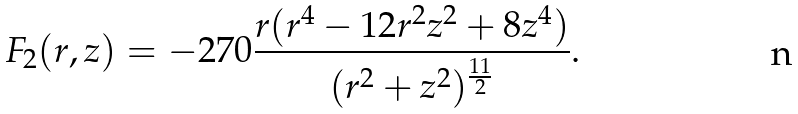Convert formula to latex. <formula><loc_0><loc_0><loc_500><loc_500>F _ { 2 } ( r , z ) = - 2 7 0 \frac { r ( r ^ { 4 } - 1 2 r ^ { 2 } z ^ { 2 } + 8 z ^ { 4 } ) } { ( r ^ { 2 } + z ^ { 2 } ) ^ { \frac { 1 1 } 2 } } .</formula> 